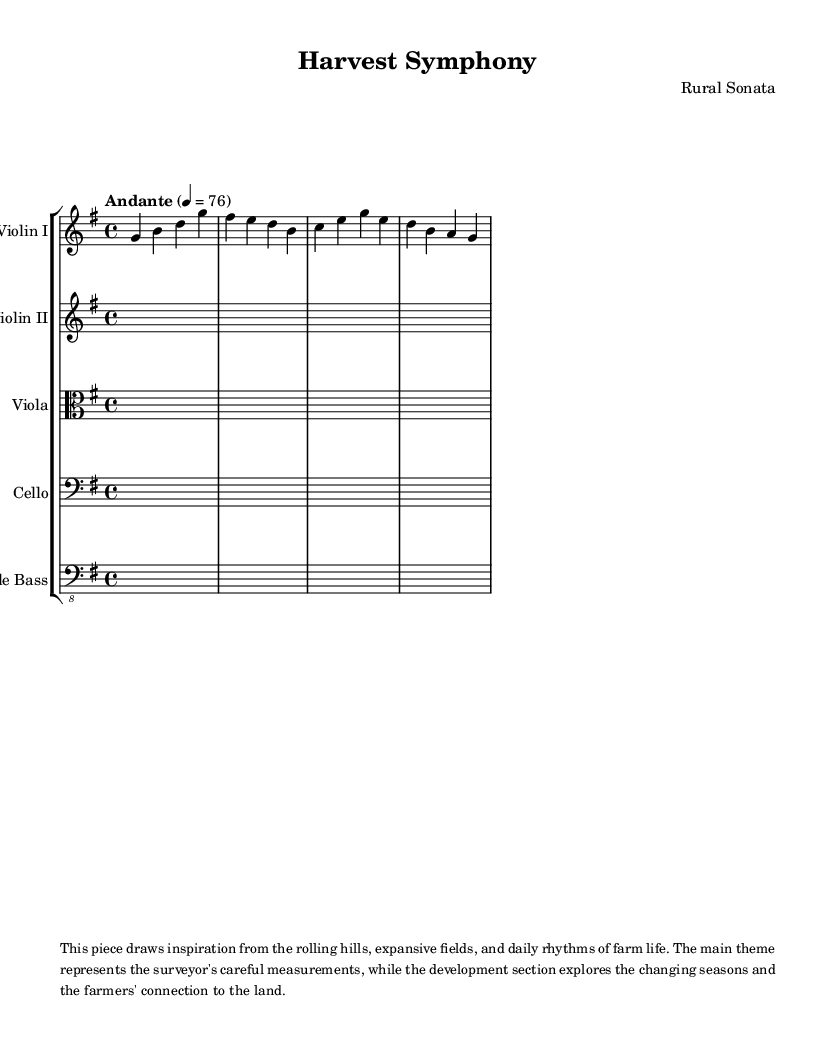What is the key signature of this music? The key signature is G major, indicated by one sharp (F#) on the staff.
Answer: G major What is the time signature of this piece? The time signature is 4/4, which can be found at the beginning of the score next to the key signature.
Answer: 4/4 What is the tempo marking indicated in the score? The tempo marking is "Andante," which is generally understood to mean a moderately slow tempo. The specific tempo is given as 76 beats per minute, appearing directly above the staff.
Answer: Andante How many measures are present in the violin I part? The violin I part consists of four measures, as indicated by the four bars drawn in the music. Each measure contains a different sequence of notes.
Answer: Four What does the piece represent according to the markup section? The piece draws inspiration from rural landscapes, representing the surveyor's careful measurements and the changing seasons. This is explicitly mentioned in the markup text.
Answer: Rural landscapes What does the term "Andante" suggest about the performance of this piece? "Andante" suggests that the piece should be played at a moderate pace, which adds to the overall serene and pastoral feel inspired by farmland and nature. This relates to the overall mood and theme presented in the music.
Answer: Moderate pace 